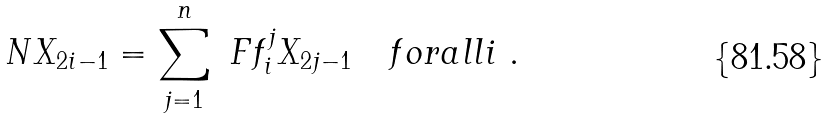<formula> <loc_0><loc_0><loc_500><loc_500>N X _ { 2 i - 1 } = \sum _ { j = 1 } ^ { n } \ F f _ { i } ^ { j } X _ { 2 j - 1 } \quad f o r a l l i \ .</formula> 